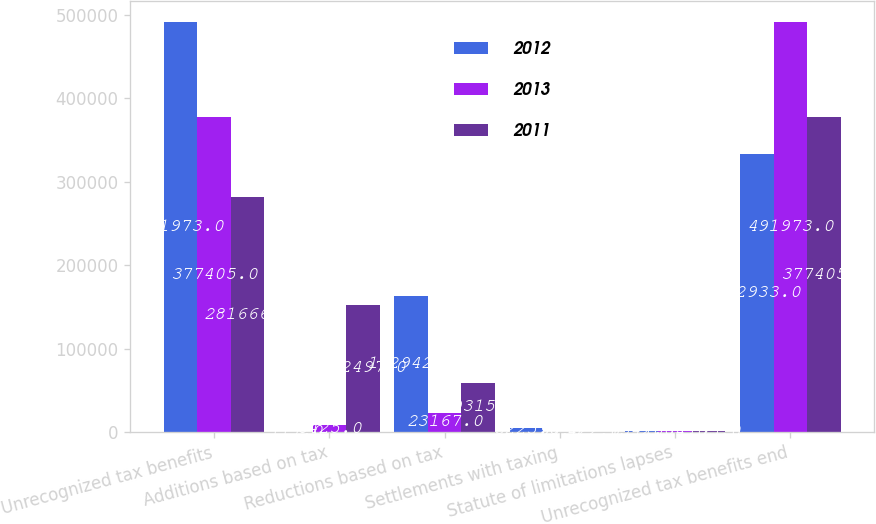Convert chart to OTSL. <chart><loc_0><loc_0><loc_500><loc_500><stacked_bar_chart><ecel><fcel>Unrecognized tax benefits<fcel>Additions based on tax<fcel>Reductions based on tax<fcel>Settlements with taxing<fcel>Statute of limitations lapses<fcel>Unrecognized tax benefits end<nl><fcel>2012<fcel>491973<fcel>117<fcel>162942<fcel>5225<fcel>1342<fcel>332933<nl><fcel>2013<fcel>377405<fcel>8425<fcel>23167<fcel>99<fcel>1034<fcel>491973<nl><fcel>2011<fcel>281666<fcel>152497<fcel>59315<fcel>422<fcel>1195<fcel>377405<nl></chart> 